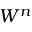Convert formula to latex. <formula><loc_0><loc_0><loc_500><loc_500>W ^ { n }</formula> 